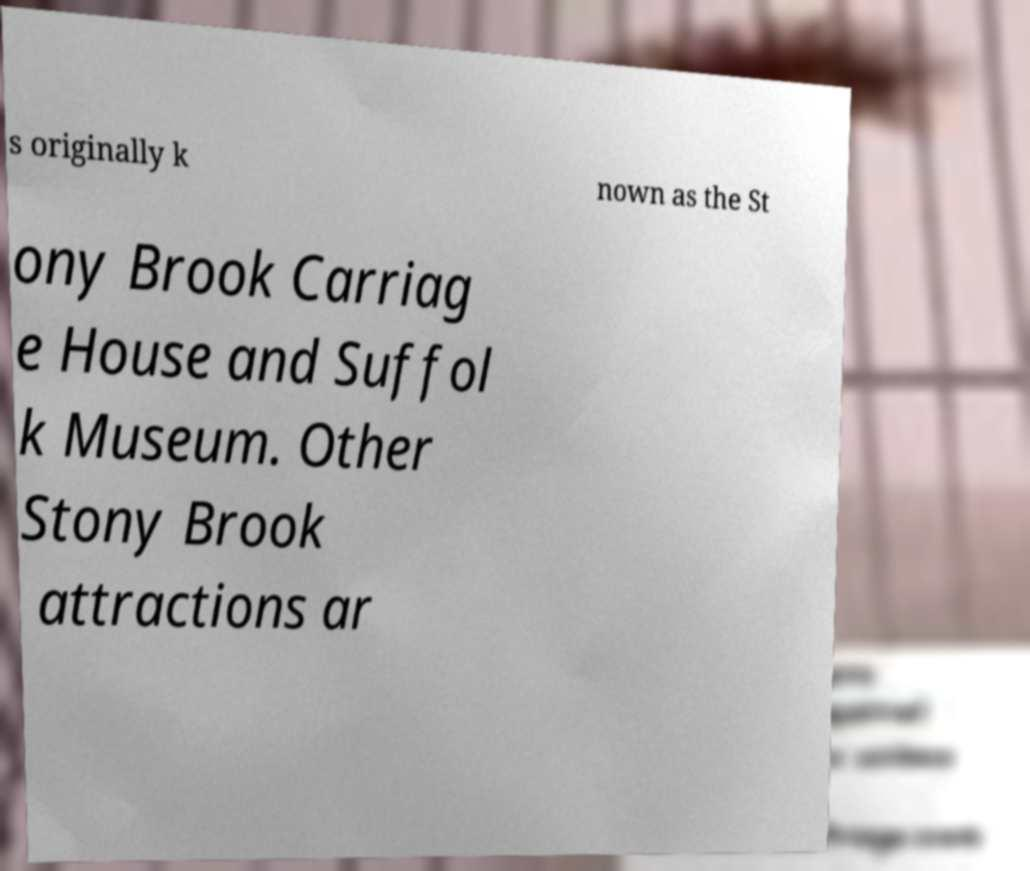There's text embedded in this image that I need extracted. Can you transcribe it verbatim? s originally k nown as the St ony Brook Carriag e House and Suffol k Museum. Other Stony Brook attractions ar 